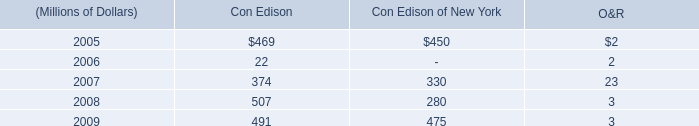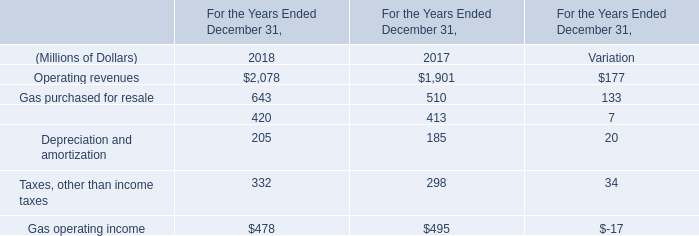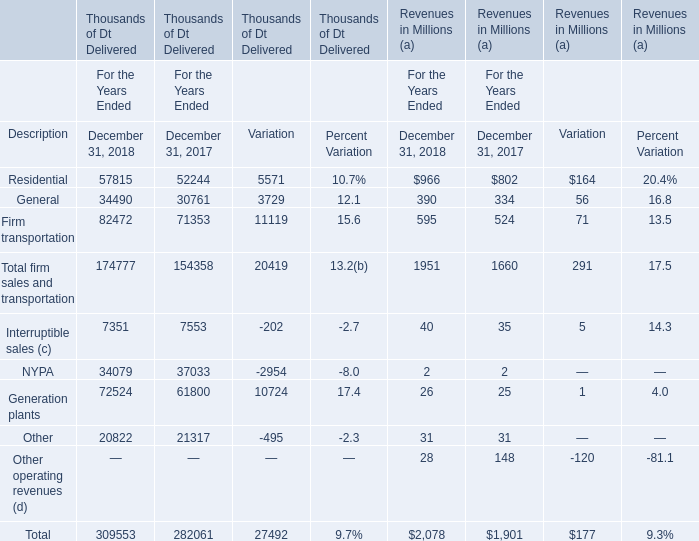In what year is Gas purchased for resale positive? 
Answer: 2018. What is the sum of the Operating revenues in the years where Gas purchased for resale is positive? (in millions) 
Computations: ((2078 + 1901) + 177)
Answer: 4156.0. 